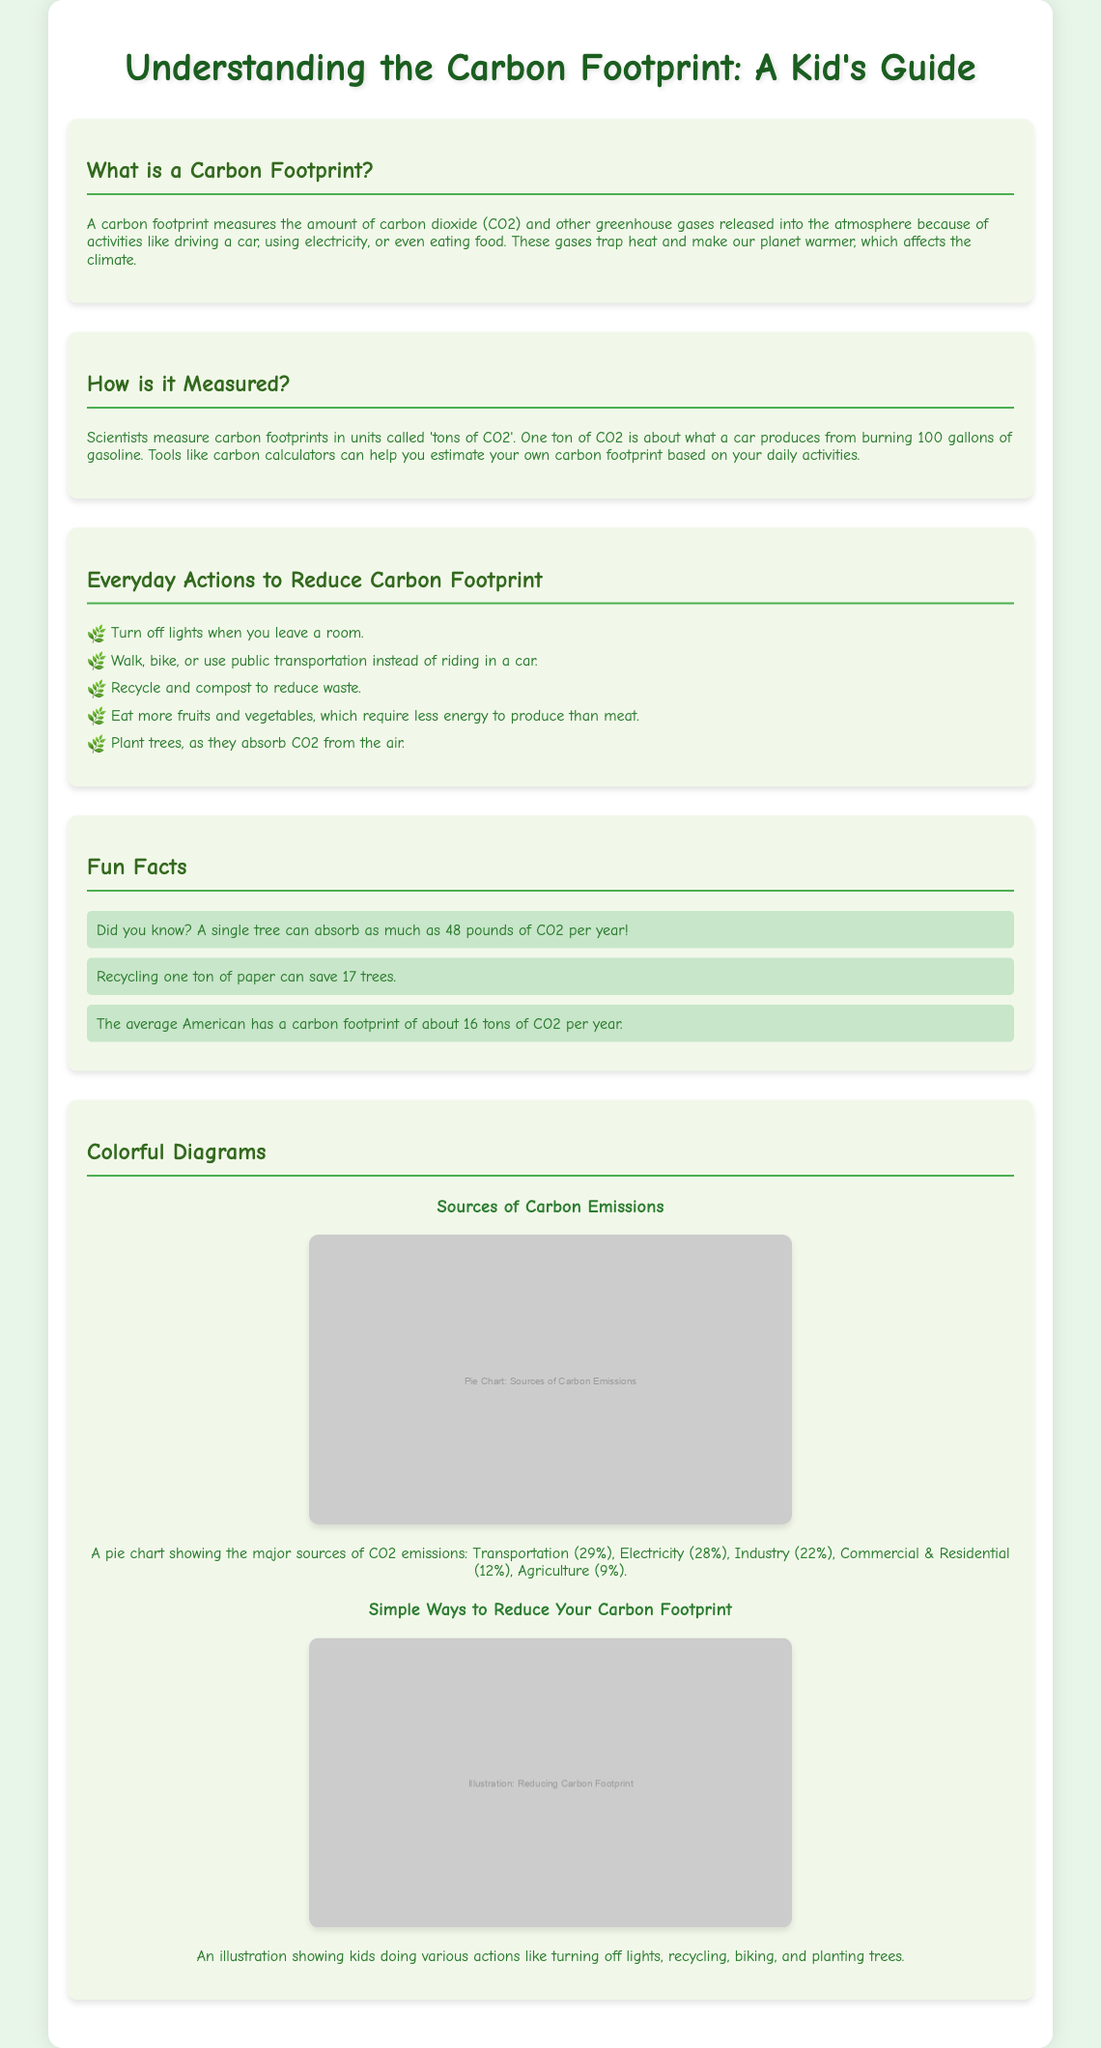What is a carbon footprint? A carbon footprint measures the amount of carbon dioxide and other greenhouse gases released into the atmosphere due to activities like driving a car, using electricity, or eating food.
Answer: A carbon footprint measures greenhouse gases How is a carbon footprint measured? A carbon footprint is measured in units called 'tons of CO2', where one ton is equivalent to the emissions from burning 100 gallons of gasoline.
Answer: Tons of CO2 What can kids do to reduce their carbon footprint? The document lists several actions like turning off lights, recycling, and planting trees that kids can take to help reduce their carbon footprint.
Answer: Turn off lights, recycle, plant trees What does a single tree absorb per year? The fun fact in the document states that a single tree can absorb as much as 48 pounds of CO2 each year.
Answer: 48 pounds What is the average carbon footprint of an American? The document mentions that the average American has a carbon footprint of about 16 tons of CO2 per year.
Answer: 16 tons What percentage of carbon emissions comes from transportation? According to the diagram, transportation accounts for 29% of the total carbon emissions.
Answer: 29% Which action saves trees according to the fun facts? The document states that recycling one ton of paper can save 17 trees.
Answer: 17 trees What type of resource is this document classified as? The layout and content suggest that this document is a magazine guide aimed at educating kids about climate change and carbon footprints.
Answer: Magazine guide 